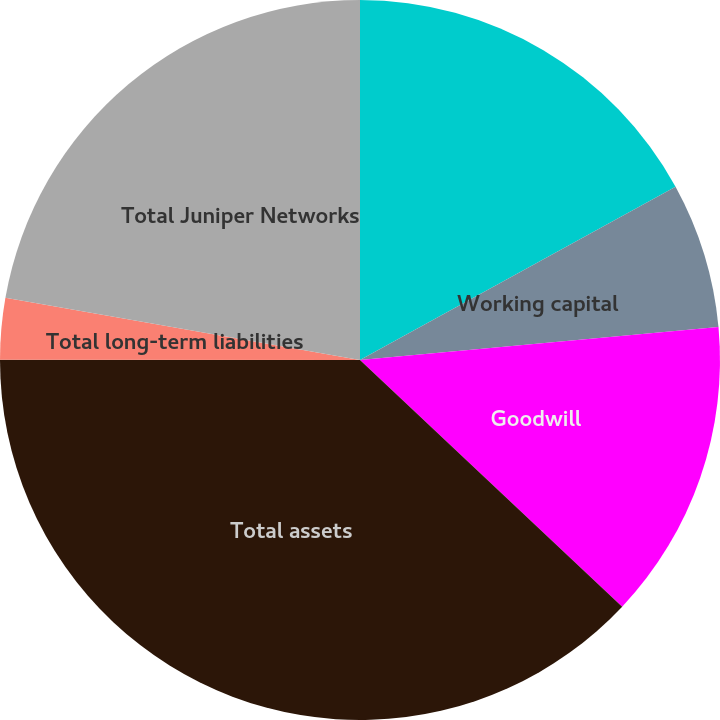Convert chart to OTSL. <chart><loc_0><loc_0><loc_500><loc_500><pie_chart><fcel>Cash cash equivalents and<fcel>Working capital<fcel>Goodwill<fcel>Total assets<fcel>Total long-term liabilities<fcel>Total Juniper Networks<nl><fcel>17.01%<fcel>6.53%<fcel>13.48%<fcel>38.0%<fcel>2.75%<fcel>22.24%<nl></chart> 